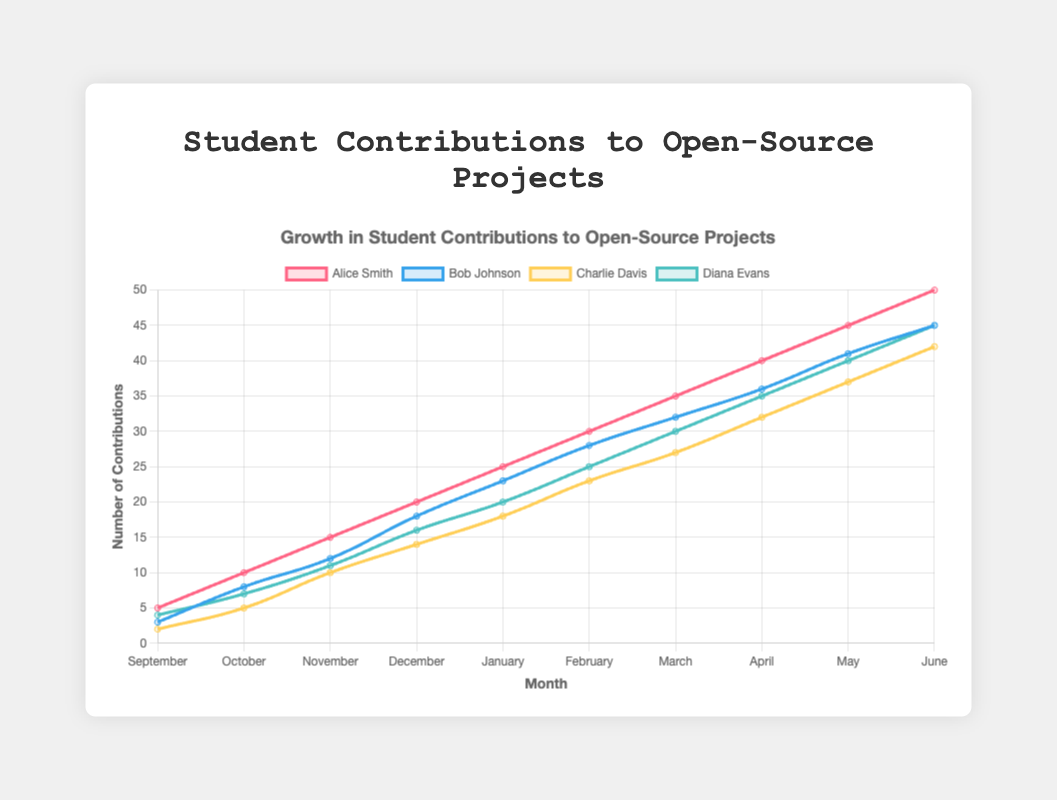What is the total number of contributions made by Alice Smith in the entire school year? Sum the contributions made by Alice Smith in each month: 5 (September) + 10 (October) + 15 (November) + 20 (December) + 25 (January) + 30 (February) + 35 (March) + 40 (April) + 45 (May) + 50 (June) = 275
Answer: 275 Who has the highest number of contributions in June? Compare the contributions by each student in June: Alice Smith (50), Bob Johnson (45), Charlie Davis (42), Diana Evans (45). Alice Smith has the highest number.
Answer: Alice Smith By how many contributions did Bob Johnson's contributions increase from January to June? Subtract Bob Johnson's contributions in January from those in June: 45 (June) - 23 (January) = 22
Answer: 22 Which student had the least number of contributions in September? Compare the contributions by each student in September: Alice Smith (5), Bob Johnson (3), Charlie Davis (2), Diana Evans (4). Charlie Davis has the least number.
Answer: Charlie Davis What is the average number of contributions per month for Diana Evans over the year? Sum Diana Evans' contributions over the 10 months and divide by 10: (4 + 7 + 11 + 16 + 20 + 25 + 30 + 35 + 40 + 45)/10 = 23.3
Answer: 23.3 Which month's average contribution among all students is the highest? Calculate the average contribution for each month and compare them:
- Sep: (5+3+2+4)/4 = 3.5
- Oct: (10+8+5+7)/4 = 7.5
- Nov: (15+12+10+11)/4 = 12
- Dec: (20+18+14+16)/4 = 17
- Jan: (25+23+18+20)/4 = 21.5
- Feb: (30+28+23+25)/4 = 26.5
- Mar: (35+32+27+30)/4 = 31
- Apr: (40+36+32+35)/4 = 35.75
- May: (45+41+37+40)/4 = 40.75
- Jun: (50+45+42+45)/4 = 45.5
June has the highest average contribution.
Answer: June Which student shows the most consistent monthly growth in contributions? Alice Smith shows a steady increment of 5 contributions each month, from 5 in September to 50 in June.
Answer: Alice Smith What is the combined number of contributions by Charlie Davis and Diana Evans in March? Sum up the contributions by Charlie Davis and Diana Evans in March: 27 + 30 = 57
Answer: 57 Between December and January, whose contributions increased the most? Compare the differences for each student: Alice Smith (25-20 = 5), Bob Johnson (23-18 = 5), Charlie Davis (18-14 = 4), Diana Evans (20-16 = 4). Both Alice Smith and Bob Johnson have the highest increase of 5 contributions.
Answer: Alice Smith and Bob Johnson Which students have the same number of contributions in any month? Compare contributions for each month:
- June: Bob Johnson and Diana Evans both have 45 contributions.
Only in June, both Bob Johnson and Diana Evans have the same number of contributions.
Answer: Bob Johnson and Diana Evans 